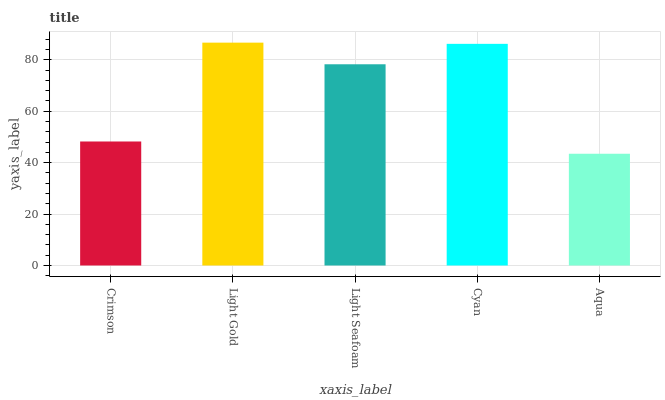Is Aqua the minimum?
Answer yes or no. Yes. Is Light Gold the maximum?
Answer yes or no. Yes. Is Light Seafoam the minimum?
Answer yes or no. No. Is Light Seafoam the maximum?
Answer yes or no. No. Is Light Gold greater than Light Seafoam?
Answer yes or no. Yes. Is Light Seafoam less than Light Gold?
Answer yes or no. Yes. Is Light Seafoam greater than Light Gold?
Answer yes or no. No. Is Light Gold less than Light Seafoam?
Answer yes or no. No. Is Light Seafoam the high median?
Answer yes or no. Yes. Is Light Seafoam the low median?
Answer yes or no. Yes. Is Light Gold the high median?
Answer yes or no. No. Is Aqua the low median?
Answer yes or no. No. 